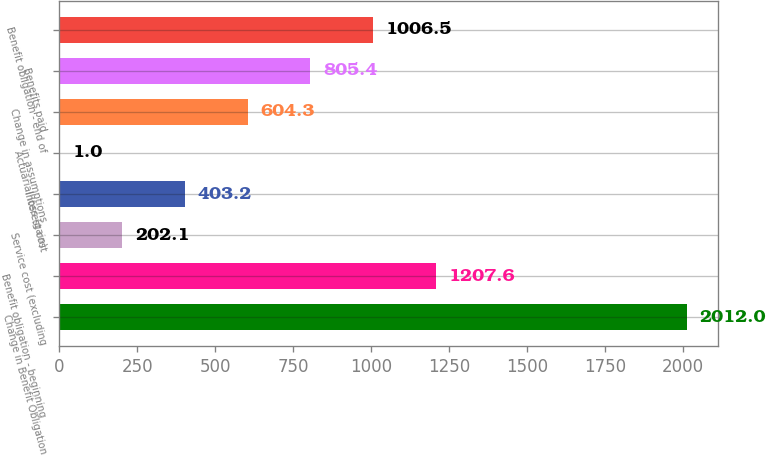Convert chart. <chart><loc_0><loc_0><loc_500><loc_500><bar_chart><fcel>Change in Benefit Obligation<fcel>Benefit obligation - beginning<fcel>Service cost (excluding<fcel>Interest cost<fcel>Actuarial loss (gain)<fcel>Change in assumptions<fcel>Benefits paid<fcel>Benefit obligation - end of<nl><fcel>2012<fcel>1207.6<fcel>202.1<fcel>403.2<fcel>1<fcel>604.3<fcel>805.4<fcel>1006.5<nl></chart> 